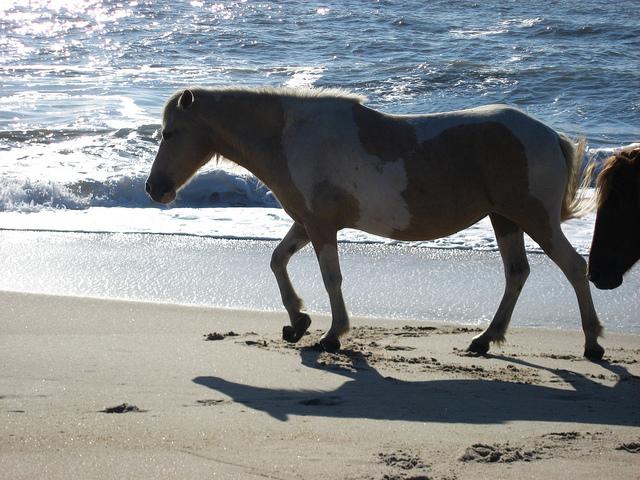Where is the horse?
Be succinct. Beach. What type of marks has the horse made?
Write a very short answer. Hoof prints. Is he making tracks?
Answer briefly. Yes. 